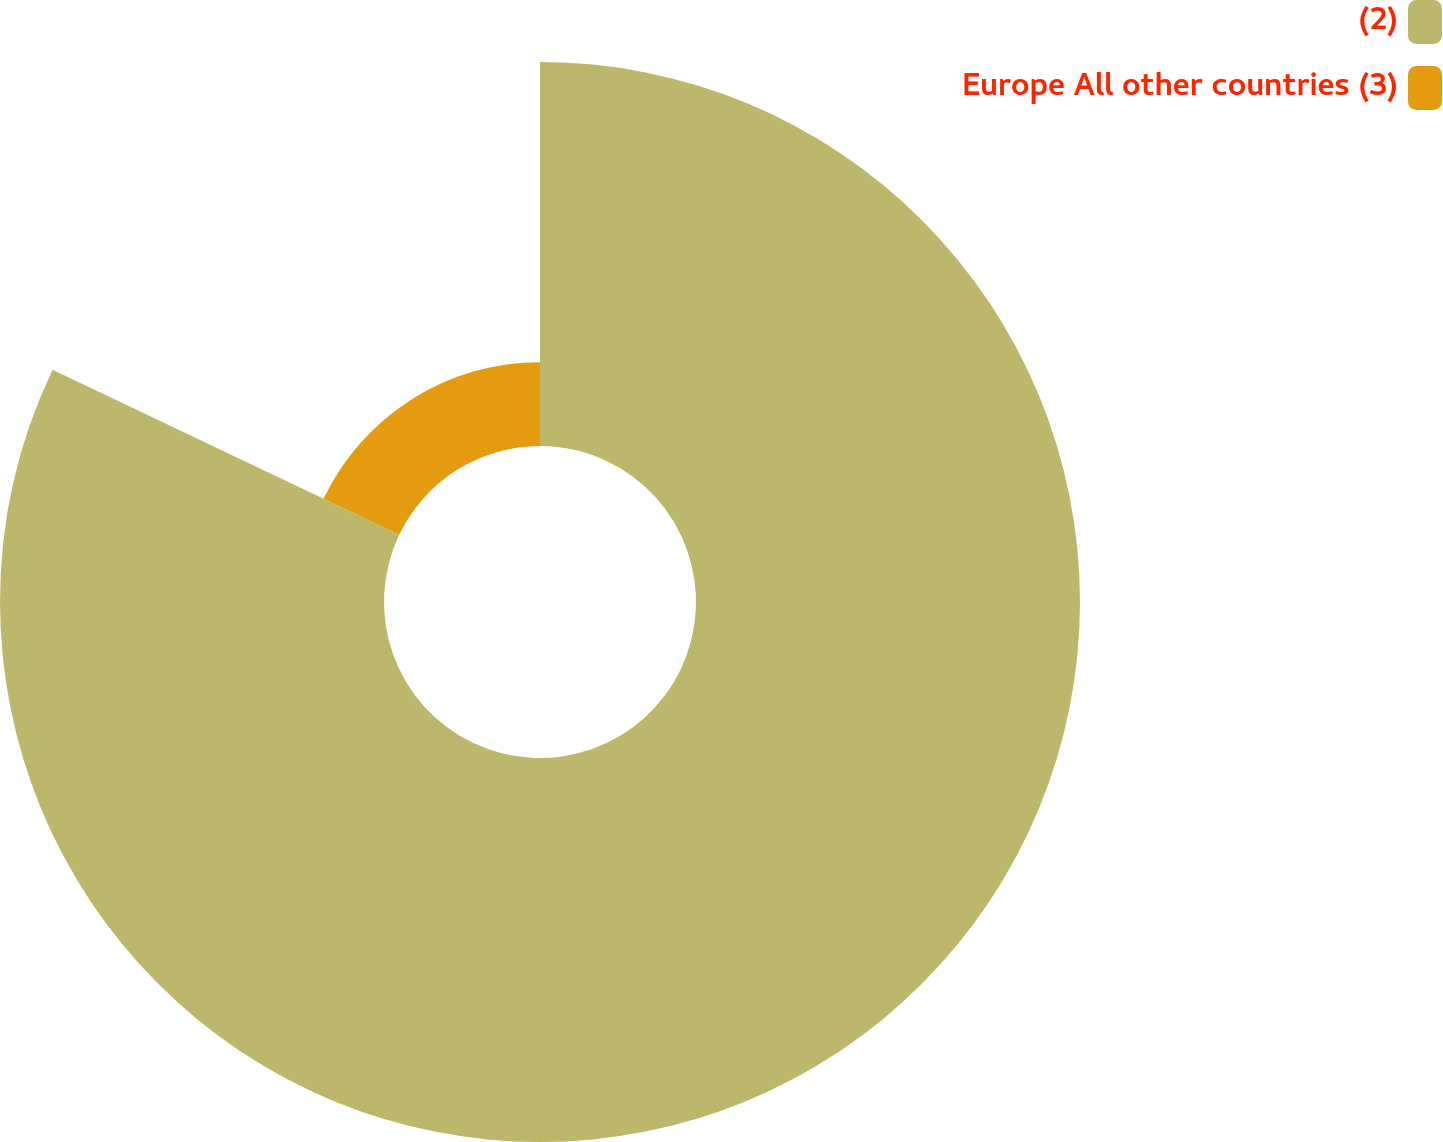<chart> <loc_0><loc_0><loc_500><loc_500><pie_chart><fcel>(2)<fcel>Europe All other countries (3)<nl><fcel>82.08%<fcel>17.92%<nl></chart> 